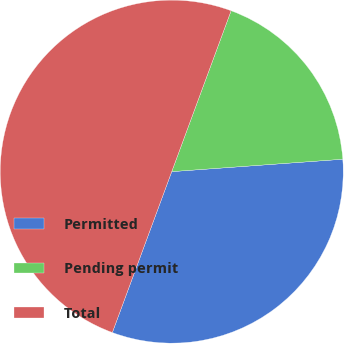Convert chart. <chart><loc_0><loc_0><loc_500><loc_500><pie_chart><fcel>Permitted<fcel>Pending permit<fcel>Total<nl><fcel>31.78%<fcel>18.22%<fcel>50.0%<nl></chart> 